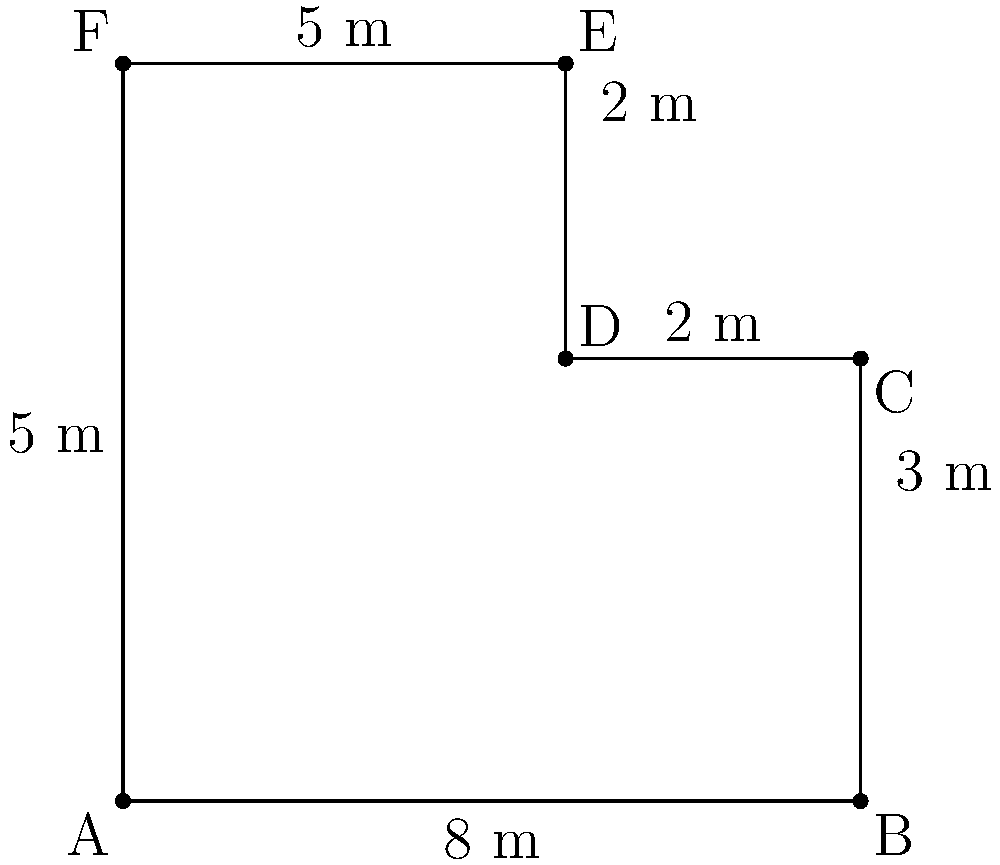Your grandparent is planning to fence their uniquely shaped garden plot. They've asked for your help in calculating the total length of fencing needed. Using the measurements provided in the diagram, what is the perimeter of the garden plot? Let's break this down step-by-step:

1) The garden plot is an irregular hexagon. To find its perimeter, we need to add up the lengths of all sides.

2) Starting from point A and moving clockwise:
   - Side AB = 8 m
   - Side BC = 3 m
   - Side CD = 2 m
   - Side DE = 2 m
   - Side EF = 5 m
   - Side FA = 5 m

3) Now, let's add all these lengths:
   
   $$\text{Perimeter} = 8 + 3 + 2 + 2 + 5 + 5 = 25\text{ m}$$

4) Therefore, the total length of fencing needed is 25 meters.

You can explain to your grandparent that they'll need to purchase 25 meters of fencing material to enclose the entire garden plot.
Answer: 25 m 